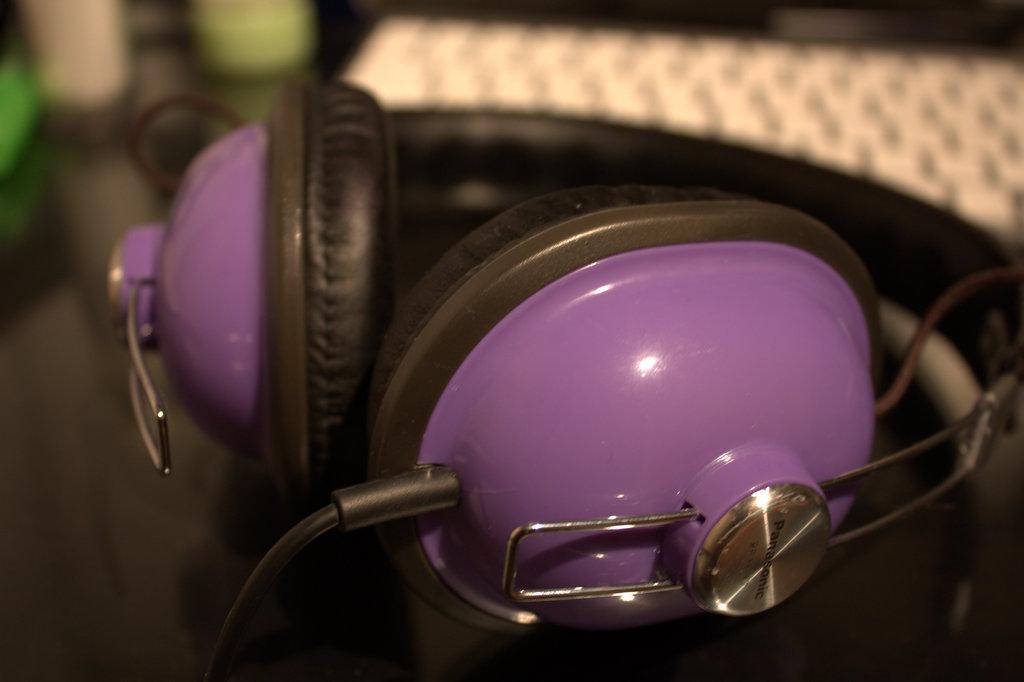Please provide a concise description of this image. There is a purple and a black color headphones. In the background it is blurred. 